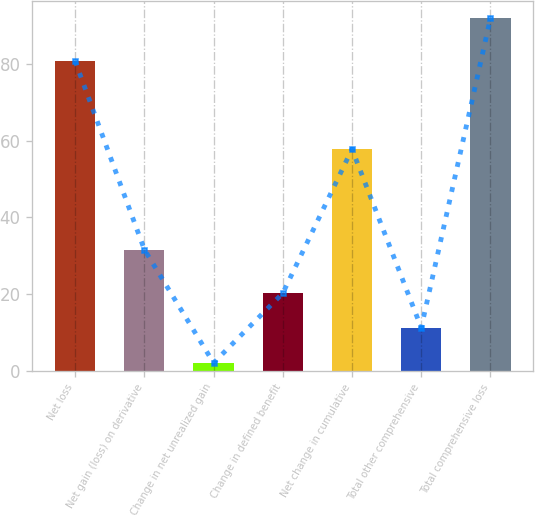<chart> <loc_0><loc_0><loc_500><loc_500><bar_chart><fcel>Net loss<fcel>Net gain (loss) on derivative<fcel>Change in net unrealized gain<fcel>Change in defined benefit<fcel>Net change in cumulative<fcel>Total other comprehensive<fcel>Total comprehensive loss<nl><fcel>80.8<fcel>31.6<fcel>2<fcel>20.2<fcel>57.8<fcel>11.2<fcel>92<nl></chart> 